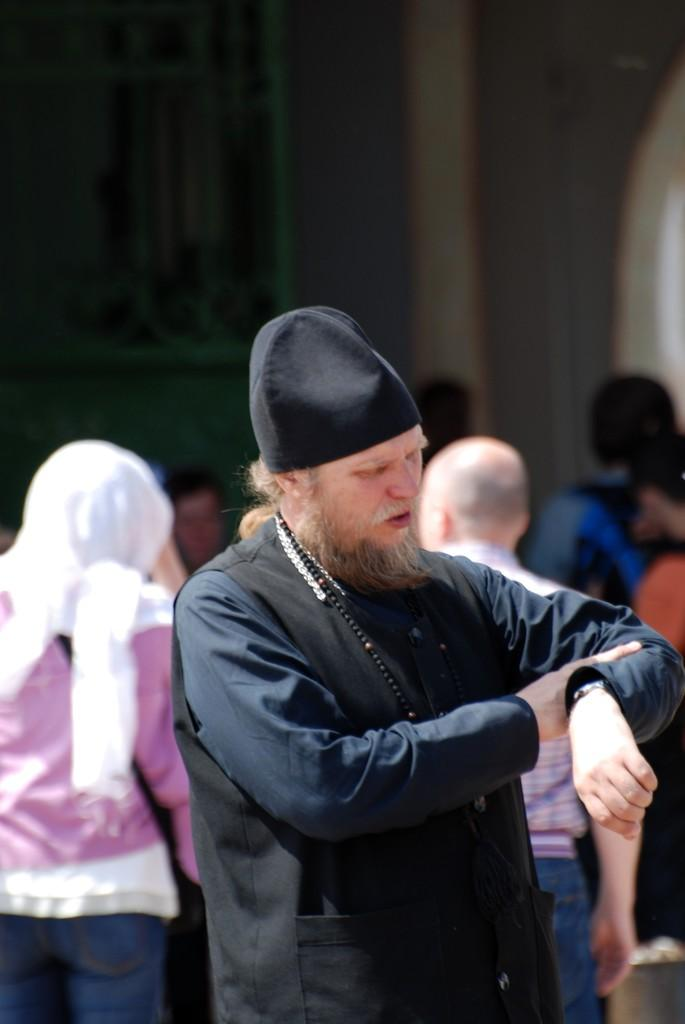Who is the main subject in the image? There is a man in the image. What is the man doing in the image? The man is looking at his watch. Can you describe the background of the image? There are other people in the background of the image, and the background of the man is blurred. What type of nut is being used to tie the string in the image? There is no nut or string present in the image. 